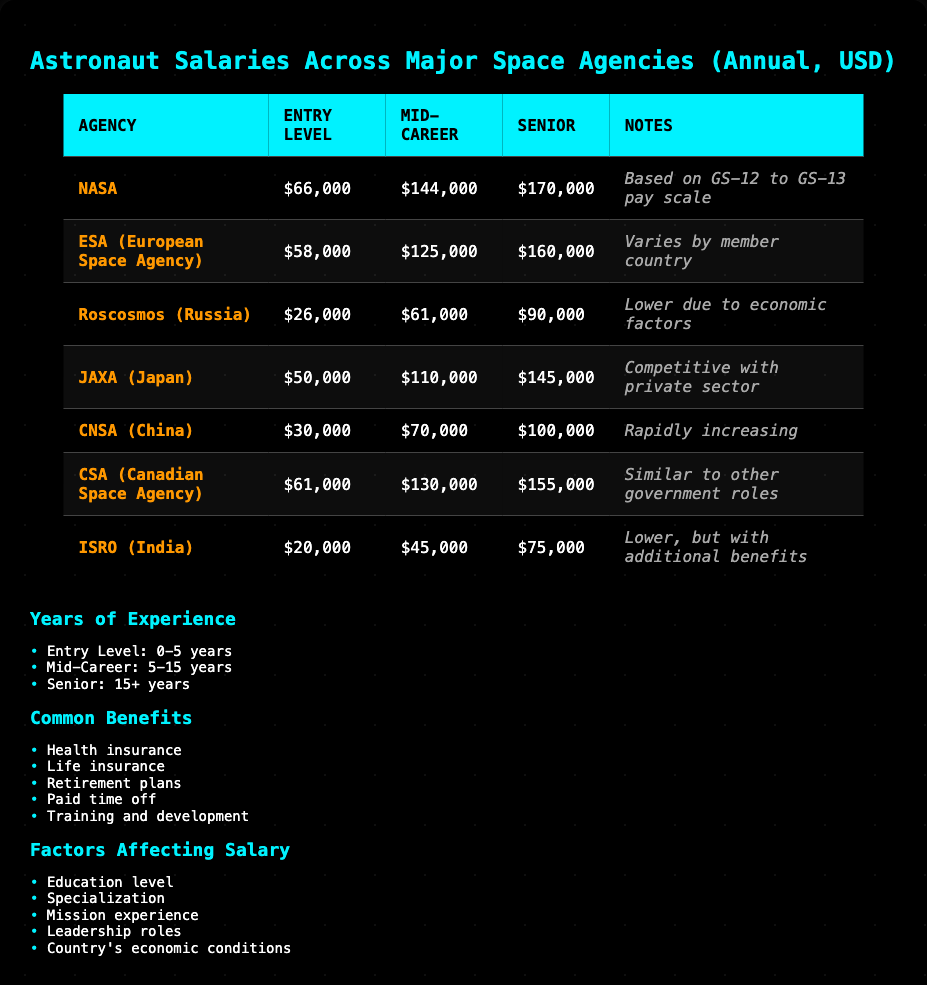What is the entry-level salary for NASA astronauts? The table indicates that NASA's entry-level salary is listed as $66,000.
Answer: $66,000 Which agency offers the highest senior salary? The senior salary for NASA is $170,000, which is higher than any other agency listed in the table.
Answer: NASA What is the average mid-career salary across all listed agencies? The mid-career salaries for the agencies are $144,000 (NASA), $125,000 (ESA), $61,000 (Roscosmos), $110,000 (JAXA), $70,000 (CNSA), $130,000 (CSA), and $45,000 (ISRO). Summing these gives $144,000 + $125,000 + $61,000 + $110,000 + $70,000 + $130,000 + $45,000 = $785,000. Dividing by 7 (number of agencies) gives an average of $785,000 / 7 = $112,143.
Answer: $112,143 Is the entry-level salary for astronauts in ISRO higher than that in Roscosmos? ISRO has an entry-level salary of $20,000, while Roscosmos has $26,000. Since $20,000 is less than $26,000, the statement is false.
Answer: No What is the difference in senior salaries between CSA and JAXA? The senior salary for CSA is $155,000 and for JAXA it is $145,000. The difference is $155,000 - $145,000 = $10,000.
Answer: $10,000 Which agency has both the lowest entry-level salary and the lowest mid-career salary? ISRO has the lowest entry-level salary at $20,000 and a mid-career salary of $45,000, which is also the lowest among the agencies.
Answer: ISRO Are there any agencies that offer a higher mid-career salary than NASA? NASA's mid-career salary is $144,000, and no other agency's mid-career salary listed in the table exceeds this amount, confirming the fact as true.
Answer: No 